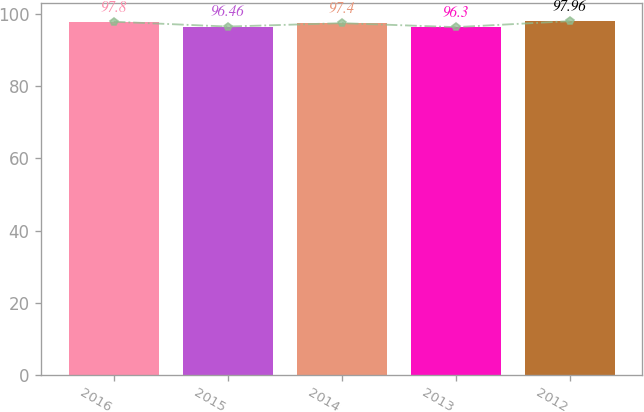<chart> <loc_0><loc_0><loc_500><loc_500><bar_chart><fcel>2016<fcel>2015<fcel>2014<fcel>2013<fcel>2012<nl><fcel>97.8<fcel>96.46<fcel>97.4<fcel>96.3<fcel>97.96<nl></chart> 